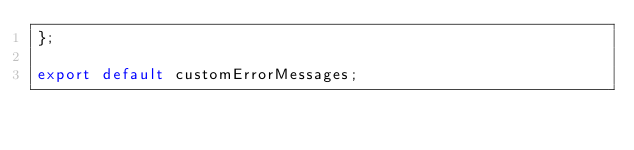<code> <loc_0><loc_0><loc_500><loc_500><_JavaScript_>};

export default customErrorMessages;
</code> 